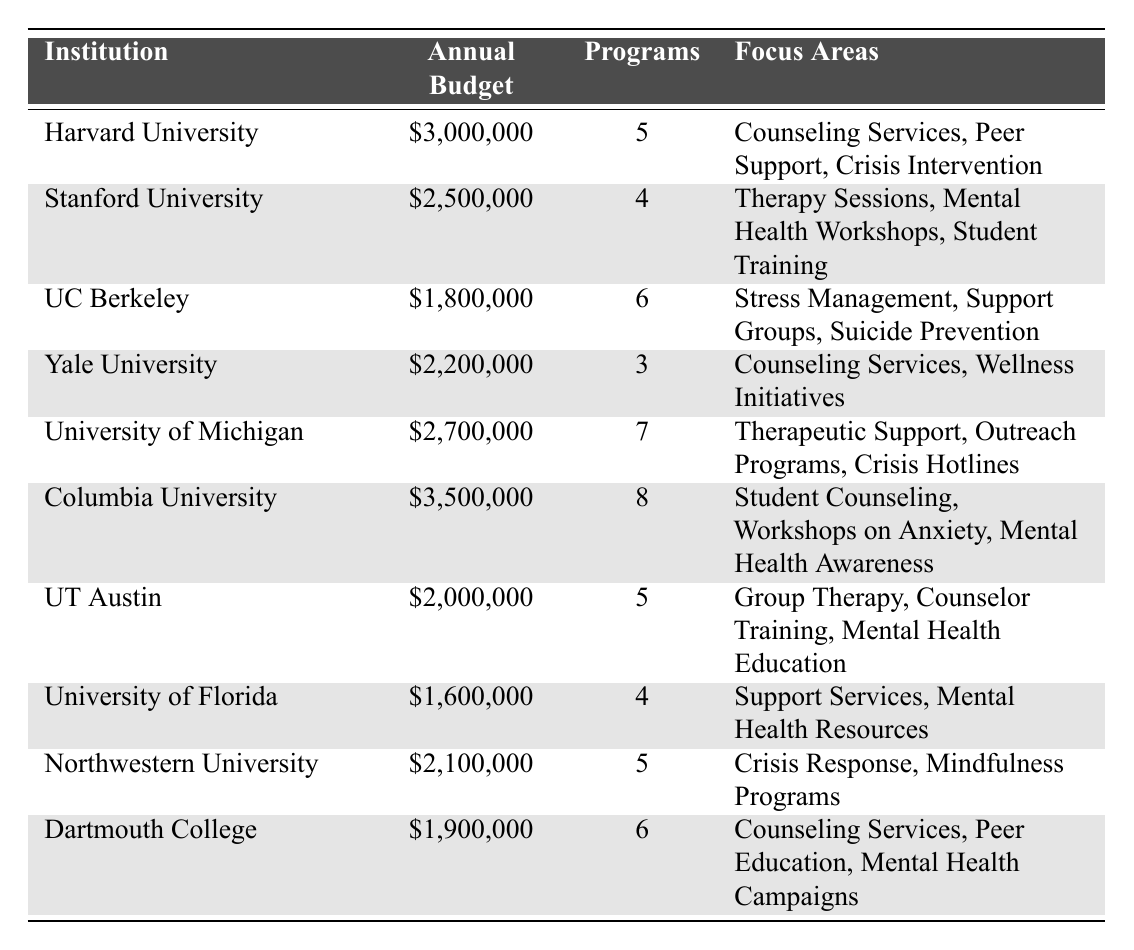What is the institution with the highest annual budget allocation for mental health programs? By examining the "Annual Budget" column, Columbia University has the highest allocation of \$3,500,000.
Answer: Columbia University How many programs are funded by the University of Michigan? In the "Programs" column, the University of Michigan has 7 programs funded listed next to its name.
Answer: 7 Which institution focuses on peer support and crisis intervention? Harvard University has both "Peer Support" and "Crisis Intervention" listed in its "Focus Areas".
Answer: Harvard University What is the total annual budget for all institutions listed in the table? Adding the annual budgets: 3,000,000 + 2,500,000 + 1,800,000 + 2,200,000 + 2,700,000 + 3,500,000 + 2,000,000 + 1,600,000 + 2,100,000 + 1,900,000 gives 22,100,000.
Answer: \$22,100,000 Does the University of Florida have more programs funded than Yale University? The University of Florida has 4 programs funded, while Yale University has 3. Therefore, it is true that the University of Florida has more programs.
Answer: Yes Which institution has the lowest annual budget allocation, and how much is it? The lowest allocation in the "Annual Budget" column is \$1,600,000 for the University of Florida.
Answer: University of Florida, \$1,600,000 If we consider only the institutions that fund more than 5 programs, what is the average annual budget among them? Institutions funding more than 5 programs: University of Michigan (2,700,000), Columbia University (3,500,000), UC Berkeley (1,800,000). The total budget is 2,700,000 + 3,500,000 + 1,800,000 = 8,000,000 with 3 data points. The average is 8,000,000 / 3 = 2,666,667.
Answer: \$2,666,667 How many institutions focus on "Counseling Services" as a focus area? Checking the "Focus Areas" reveals that both Harvard University and Yale University list "Counseling Services", making it 2 institutions.
Answer: 2 What is the difference between the budgets of Harvard University and Northwestern University? Harvard University has \$3,000,000, while Northwestern University has \$2,100,000. The difference is 3,000,000 - 2,100,000 = 900,000.
Answer: \$900,000 Is there an institution that offers a focus area related to mental health awareness? From the "Focus Areas", Columbia University includes "Mental Health Awareness", making that statement true.
Answer: Yes 